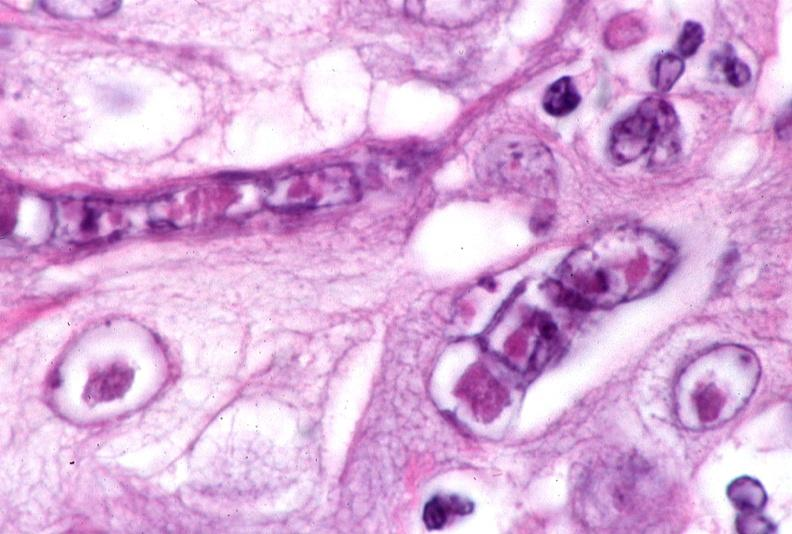does close-up tumor well shown primary not stated show skin, herpes inclusions?
Answer the question using a single word or phrase. No 